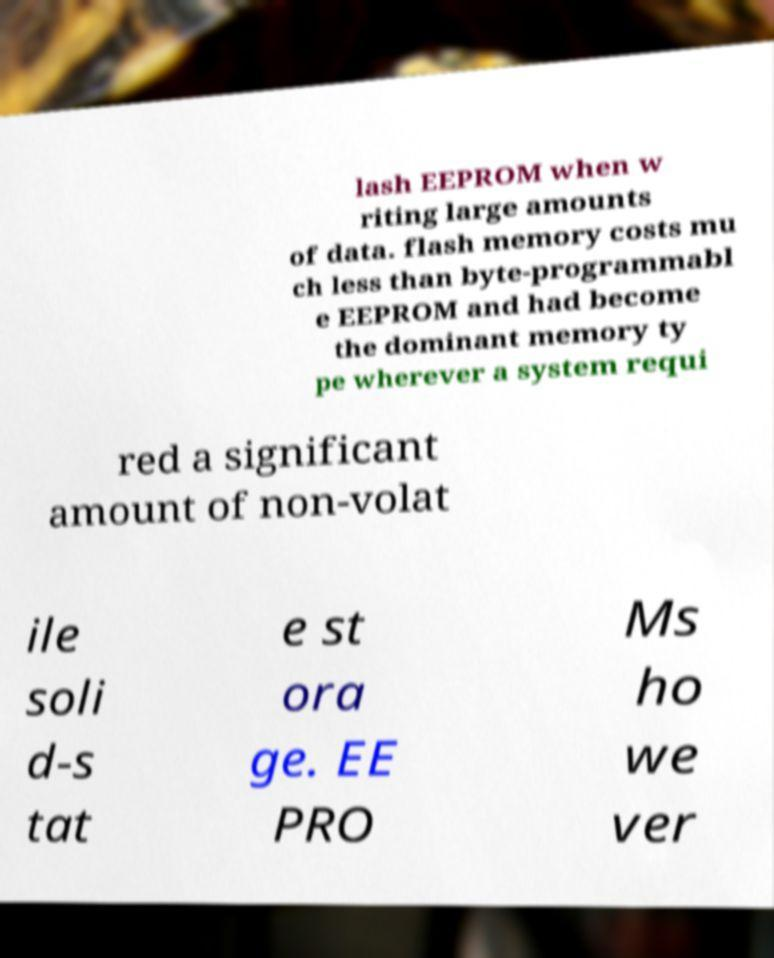Could you extract and type out the text from this image? lash EEPROM when w riting large amounts of data. flash memory costs mu ch less than byte-programmabl e EEPROM and had become the dominant memory ty pe wherever a system requi red a significant amount of non-volat ile soli d-s tat e st ora ge. EE PRO Ms ho we ver 